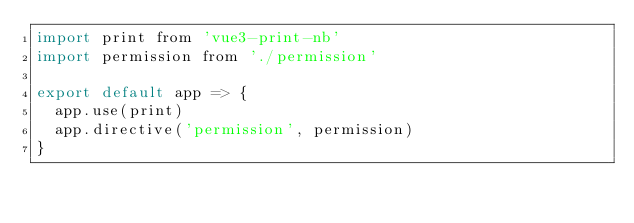<code> <loc_0><loc_0><loc_500><loc_500><_JavaScript_>import print from 'vue3-print-nb'
import permission from './permission'

export default app => {
  app.use(print)
  app.directive('permission', permission)
}
</code> 